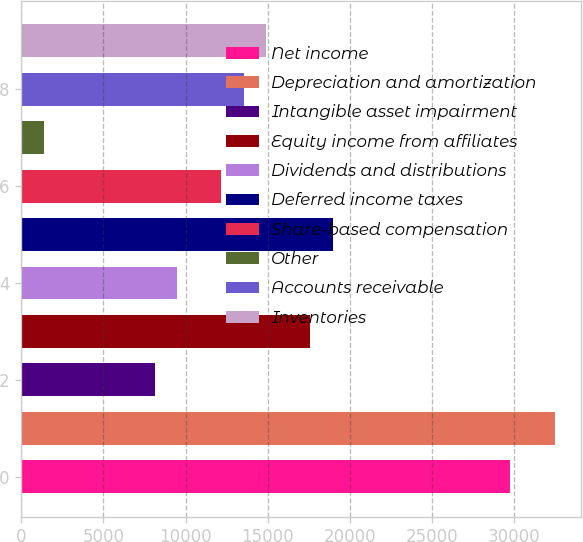Convert chart. <chart><loc_0><loc_0><loc_500><loc_500><bar_chart><fcel>Net income<fcel>Depreciation and amortization<fcel>Intangible asset impairment<fcel>Equity income from affiliates<fcel>Dividends and distributions<fcel>Deferred income taxes<fcel>Share-based compensation<fcel>Other<fcel>Accounts receivable<fcel>Inventories<nl><fcel>29741.8<fcel>32443.6<fcel>8127.4<fcel>17583.7<fcel>9478.3<fcel>18934.6<fcel>12180.1<fcel>1372.9<fcel>13531<fcel>14881.9<nl></chart> 